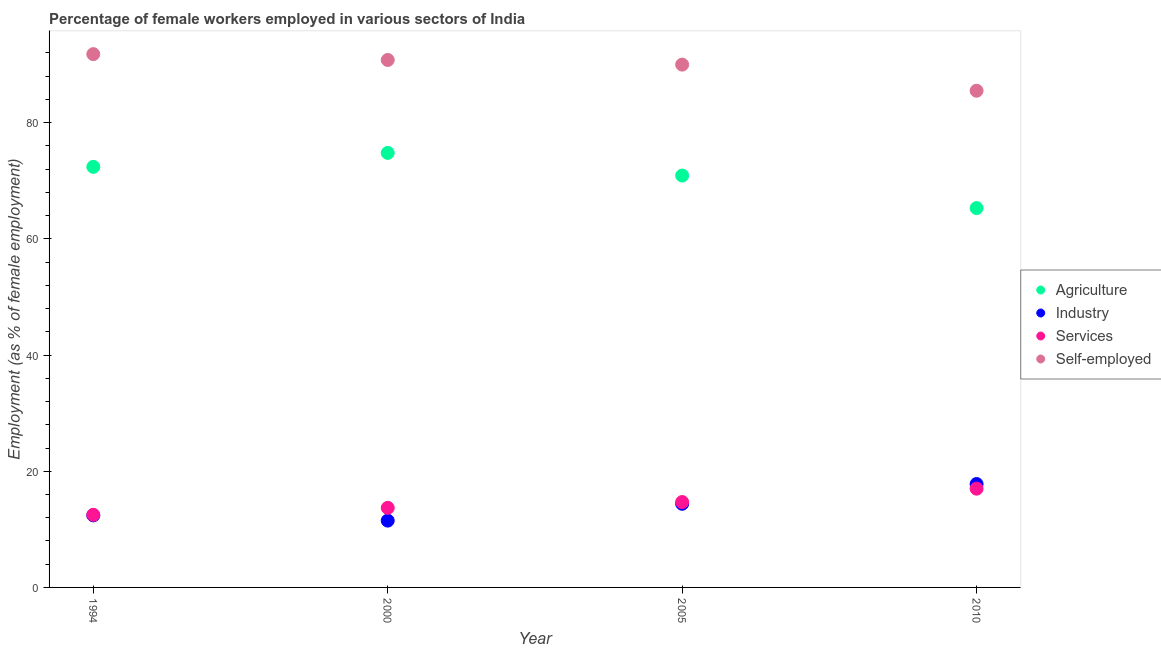How many different coloured dotlines are there?
Make the answer very short. 4. Is the number of dotlines equal to the number of legend labels?
Your answer should be compact. Yes. What is the percentage of female workers in industry in 1994?
Your answer should be compact. 12.4. Across all years, what is the maximum percentage of self employed female workers?
Your response must be concise. 91.8. In which year was the percentage of female workers in agriculture maximum?
Keep it short and to the point. 2000. In which year was the percentage of female workers in agriculture minimum?
Make the answer very short. 2010. What is the total percentage of female workers in industry in the graph?
Your answer should be very brief. 56.1. What is the difference between the percentage of self employed female workers in 2000 and that in 2005?
Keep it short and to the point. 0.8. What is the difference between the percentage of female workers in agriculture in 2000 and the percentage of self employed female workers in 2005?
Give a very brief answer. -15.2. What is the average percentage of self employed female workers per year?
Your answer should be compact. 89.53. In the year 1994, what is the difference between the percentage of female workers in agriculture and percentage of female workers in services?
Offer a terse response. 59.9. In how many years, is the percentage of female workers in services greater than 80 %?
Provide a succinct answer. 0. What is the ratio of the percentage of female workers in industry in 1994 to that in 2010?
Your response must be concise. 0.7. Is the percentage of self employed female workers in 2005 less than that in 2010?
Give a very brief answer. No. Is the difference between the percentage of female workers in agriculture in 1994 and 2005 greater than the difference between the percentage of self employed female workers in 1994 and 2005?
Your answer should be very brief. No. What is the difference between the highest and the second highest percentage of self employed female workers?
Provide a short and direct response. 1. What is the difference between the highest and the lowest percentage of female workers in industry?
Your response must be concise. 6.3. In how many years, is the percentage of self employed female workers greater than the average percentage of self employed female workers taken over all years?
Provide a succinct answer. 3. Is the sum of the percentage of female workers in agriculture in 1994 and 2000 greater than the maximum percentage of female workers in services across all years?
Make the answer very short. Yes. Is it the case that in every year, the sum of the percentage of female workers in agriculture and percentage of female workers in industry is greater than the percentage of female workers in services?
Offer a very short reply. Yes. Does the percentage of self employed female workers monotonically increase over the years?
Give a very brief answer. No. Is the percentage of self employed female workers strictly greater than the percentage of female workers in industry over the years?
Offer a very short reply. Yes. Does the graph contain any zero values?
Give a very brief answer. No. Does the graph contain grids?
Offer a terse response. No. Where does the legend appear in the graph?
Ensure brevity in your answer.  Center right. How many legend labels are there?
Your response must be concise. 4. How are the legend labels stacked?
Provide a succinct answer. Vertical. What is the title of the graph?
Make the answer very short. Percentage of female workers employed in various sectors of India. Does "WFP" appear as one of the legend labels in the graph?
Offer a terse response. No. What is the label or title of the X-axis?
Keep it short and to the point. Year. What is the label or title of the Y-axis?
Ensure brevity in your answer.  Employment (as % of female employment). What is the Employment (as % of female employment) of Agriculture in 1994?
Ensure brevity in your answer.  72.4. What is the Employment (as % of female employment) of Industry in 1994?
Give a very brief answer. 12.4. What is the Employment (as % of female employment) of Self-employed in 1994?
Offer a very short reply. 91.8. What is the Employment (as % of female employment) of Agriculture in 2000?
Offer a terse response. 74.8. What is the Employment (as % of female employment) of Services in 2000?
Provide a short and direct response. 13.7. What is the Employment (as % of female employment) of Self-employed in 2000?
Your response must be concise. 90.8. What is the Employment (as % of female employment) of Agriculture in 2005?
Make the answer very short. 70.9. What is the Employment (as % of female employment) in Industry in 2005?
Provide a succinct answer. 14.4. What is the Employment (as % of female employment) in Services in 2005?
Provide a short and direct response. 14.7. What is the Employment (as % of female employment) in Agriculture in 2010?
Offer a terse response. 65.3. What is the Employment (as % of female employment) in Industry in 2010?
Make the answer very short. 17.8. What is the Employment (as % of female employment) in Self-employed in 2010?
Your response must be concise. 85.5. Across all years, what is the maximum Employment (as % of female employment) of Agriculture?
Keep it short and to the point. 74.8. Across all years, what is the maximum Employment (as % of female employment) of Industry?
Offer a very short reply. 17.8. Across all years, what is the maximum Employment (as % of female employment) in Self-employed?
Provide a short and direct response. 91.8. Across all years, what is the minimum Employment (as % of female employment) in Agriculture?
Provide a short and direct response. 65.3. Across all years, what is the minimum Employment (as % of female employment) of Industry?
Your response must be concise. 11.5. Across all years, what is the minimum Employment (as % of female employment) of Services?
Offer a terse response. 12.5. Across all years, what is the minimum Employment (as % of female employment) in Self-employed?
Your answer should be very brief. 85.5. What is the total Employment (as % of female employment) of Agriculture in the graph?
Ensure brevity in your answer.  283.4. What is the total Employment (as % of female employment) in Industry in the graph?
Offer a very short reply. 56.1. What is the total Employment (as % of female employment) of Services in the graph?
Offer a very short reply. 57.9. What is the total Employment (as % of female employment) of Self-employed in the graph?
Offer a very short reply. 358.1. What is the difference between the Employment (as % of female employment) in Agriculture in 1994 and that in 2000?
Give a very brief answer. -2.4. What is the difference between the Employment (as % of female employment) in Industry in 1994 and that in 2000?
Make the answer very short. 0.9. What is the difference between the Employment (as % of female employment) in Self-employed in 1994 and that in 2000?
Provide a short and direct response. 1. What is the difference between the Employment (as % of female employment) in Agriculture in 1994 and that in 2005?
Offer a terse response. 1.5. What is the difference between the Employment (as % of female employment) of Industry in 1994 and that in 2005?
Your response must be concise. -2. What is the difference between the Employment (as % of female employment) of Services in 1994 and that in 2005?
Make the answer very short. -2.2. What is the difference between the Employment (as % of female employment) in Self-employed in 1994 and that in 2005?
Your answer should be compact. 1.8. What is the difference between the Employment (as % of female employment) of Industry in 2000 and that in 2010?
Your response must be concise. -6.3. What is the difference between the Employment (as % of female employment) of Industry in 2005 and that in 2010?
Offer a very short reply. -3.4. What is the difference between the Employment (as % of female employment) of Agriculture in 1994 and the Employment (as % of female employment) of Industry in 2000?
Keep it short and to the point. 60.9. What is the difference between the Employment (as % of female employment) of Agriculture in 1994 and the Employment (as % of female employment) of Services in 2000?
Your response must be concise. 58.7. What is the difference between the Employment (as % of female employment) of Agriculture in 1994 and the Employment (as % of female employment) of Self-employed in 2000?
Your response must be concise. -18.4. What is the difference between the Employment (as % of female employment) of Industry in 1994 and the Employment (as % of female employment) of Services in 2000?
Offer a terse response. -1.3. What is the difference between the Employment (as % of female employment) in Industry in 1994 and the Employment (as % of female employment) in Self-employed in 2000?
Your response must be concise. -78.4. What is the difference between the Employment (as % of female employment) in Services in 1994 and the Employment (as % of female employment) in Self-employed in 2000?
Your answer should be very brief. -78.3. What is the difference between the Employment (as % of female employment) of Agriculture in 1994 and the Employment (as % of female employment) of Services in 2005?
Ensure brevity in your answer.  57.7. What is the difference between the Employment (as % of female employment) of Agriculture in 1994 and the Employment (as % of female employment) of Self-employed in 2005?
Your answer should be very brief. -17.6. What is the difference between the Employment (as % of female employment) in Industry in 1994 and the Employment (as % of female employment) in Services in 2005?
Your answer should be compact. -2.3. What is the difference between the Employment (as % of female employment) in Industry in 1994 and the Employment (as % of female employment) in Self-employed in 2005?
Provide a short and direct response. -77.6. What is the difference between the Employment (as % of female employment) of Services in 1994 and the Employment (as % of female employment) of Self-employed in 2005?
Keep it short and to the point. -77.5. What is the difference between the Employment (as % of female employment) of Agriculture in 1994 and the Employment (as % of female employment) of Industry in 2010?
Provide a succinct answer. 54.6. What is the difference between the Employment (as % of female employment) in Agriculture in 1994 and the Employment (as % of female employment) in Services in 2010?
Make the answer very short. 55.4. What is the difference between the Employment (as % of female employment) of Industry in 1994 and the Employment (as % of female employment) of Self-employed in 2010?
Provide a short and direct response. -73.1. What is the difference between the Employment (as % of female employment) of Services in 1994 and the Employment (as % of female employment) of Self-employed in 2010?
Provide a succinct answer. -73. What is the difference between the Employment (as % of female employment) in Agriculture in 2000 and the Employment (as % of female employment) in Industry in 2005?
Offer a terse response. 60.4. What is the difference between the Employment (as % of female employment) of Agriculture in 2000 and the Employment (as % of female employment) of Services in 2005?
Keep it short and to the point. 60.1. What is the difference between the Employment (as % of female employment) of Agriculture in 2000 and the Employment (as % of female employment) of Self-employed in 2005?
Your answer should be very brief. -15.2. What is the difference between the Employment (as % of female employment) of Industry in 2000 and the Employment (as % of female employment) of Services in 2005?
Your answer should be compact. -3.2. What is the difference between the Employment (as % of female employment) of Industry in 2000 and the Employment (as % of female employment) of Self-employed in 2005?
Your answer should be compact. -78.5. What is the difference between the Employment (as % of female employment) of Services in 2000 and the Employment (as % of female employment) of Self-employed in 2005?
Give a very brief answer. -76.3. What is the difference between the Employment (as % of female employment) of Agriculture in 2000 and the Employment (as % of female employment) of Industry in 2010?
Give a very brief answer. 57. What is the difference between the Employment (as % of female employment) of Agriculture in 2000 and the Employment (as % of female employment) of Services in 2010?
Keep it short and to the point. 57.8. What is the difference between the Employment (as % of female employment) in Industry in 2000 and the Employment (as % of female employment) in Services in 2010?
Your response must be concise. -5.5. What is the difference between the Employment (as % of female employment) in Industry in 2000 and the Employment (as % of female employment) in Self-employed in 2010?
Make the answer very short. -74. What is the difference between the Employment (as % of female employment) in Services in 2000 and the Employment (as % of female employment) in Self-employed in 2010?
Keep it short and to the point. -71.8. What is the difference between the Employment (as % of female employment) in Agriculture in 2005 and the Employment (as % of female employment) in Industry in 2010?
Your answer should be compact. 53.1. What is the difference between the Employment (as % of female employment) in Agriculture in 2005 and the Employment (as % of female employment) in Services in 2010?
Keep it short and to the point. 53.9. What is the difference between the Employment (as % of female employment) in Agriculture in 2005 and the Employment (as % of female employment) in Self-employed in 2010?
Your answer should be very brief. -14.6. What is the difference between the Employment (as % of female employment) of Industry in 2005 and the Employment (as % of female employment) of Services in 2010?
Your answer should be compact. -2.6. What is the difference between the Employment (as % of female employment) in Industry in 2005 and the Employment (as % of female employment) in Self-employed in 2010?
Provide a succinct answer. -71.1. What is the difference between the Employment (as % of female employment) of Services in 2005 and the Employment (as % of female employment) of Self-employed in 2010?
Make the answer very short. -70.8. What is the average Employment (as % of female employment) of Agriculture per year?
Offer a very short reply. 70.85. What is the average Employment (as % of female employment) of Industry per year?
Make the answer very short. 14.03. What is the average Employment (as % of female employment) in Services per year?
Your response must be concise. 14.47. What is the average Employment (as % of female employment) of Self-employed per year?
Provide a succinct answer. 89.53. In the year 1994, what is the difference between the Employment (as % of female employment) in Agriculture and Employment (as % of female employment) in Industry?
Offer a terse response. 60. In the year 1994, what is the difference between the Employment (as % of female employment) of Agriculture and Employment (as % of female employment) of Services?
Keep it short and to the point. 59.9. In the year 1994, what is the difference between the Employment (as % of female employment) of Agriculture and Employment (as % of female employment) of Self-employed?
Provide a short and direct response. -19.4. In the year 1994, what is the difference between the Employment (as % of female employment) in Industry and Employment (as % of female employment) in Self-employed?
Provide a short and direct response. -79.4. In the year 1994, what is the difference between the Employment (as % of female employment) of Services and Employment (as % of female employment) of Self-employed?
Offer a very short reply. -79.3. In the year 2000, what is the difference between the Employment (as % of female employment) of Agriculture and Employment (as % of female employment) of Industry?
Keep it short and to the point. 63.3. In the year 2000, what is the difference between the Employment (as % of female employment) of Agriculture and Employment (as % of female employment) of Services?
Keep it short and to the point. 61.1. In the year 2000, what is the difference between the Employment (as % of female employment) of Industry and Employment (as % of female employment) of Services?
Provide a short and direct response. -2.2. In the year 2000, what is the difference between the Employment (as % of female employment) in Industry and Employment (as % of female employment) in Self-employed?
Give a very brief answer. -79.3. In the year 2000, what is the difference between the Employment (as % of female employment) in Services and Employment (as % of female employment) in Self-employed?
Make the answer very short. -77.1. In the year 2005, what is the difference between the Employment (as % of female employment) of Agriculture and Employment (as % of female employment) of Industry?
Provide a succinct answer. 56.5. In the year 2005, what is the difference between the Employment (as % of female employment) in Agriculture and Employment (as % of female employment) in Services?
Your answer should be very brief. 56.2. In the year 2005, what is the difference between the Employment (as % of female employment) in Agriculture and Employment (as % of female employment) in Self-employed?
Give a very brief answer. -19.1. In the year 2005, what is the difference between the Employment (as % of female employment) of Industry and Employment (as % of female employment) of Services?
Your answer should be very brief. -0.3. In the year 2005, what is the difference between the Employment (as % of female employment) in Industry and Employment (as % of female employment) in Self-employed?
Keep it short and to the point. -75.6. In the year 2005, what is the difference between the Employment (as % of female employment) in Services and Employment (as % of female employment) in Self-employed?
Offer a terse response. -75.3. In the year 2010, what is the difference between the Employment (as % of female employment) in Agriculture and Employment (as % of female employment) in Industry?
Provide a succinct answer. 47.5. In the year 2010, what is the difference between the Employment (as % of female employment) of Agriculture and Employment (as % of female employment) of Services?
Provide a succinct answer. 48.3. In the year 2010, what is the difference between the Employment (as % of female employment) in Agriculture and Employment (as % of female employment) in Self-employed?
Provide a succinct answer. -20.2. In the year 2010, what is the difference between the Employment (as % of female employment) in Industry and Employment (as % of female employment) in Self-employed?
Offer a terse response. -67.7. In the year 2010, what is the difference between the Employment (as % of female employment) of Services and Employment (as % of female employment) of Self-employed?
Make the answer very short. -68.5. What is the ratio of the Employment (as % of female employment) of Agriculture in 1994 to that in 2000?
Offer a very short reply. 0.97. What is the ratio of the Employment (as % of female employment) of Industry in 1994 to that in 2000?
Make the answer very short. 1.08. What is the ratio of the Employment (as % of female employment) of Services in 1994 to that in 2000?
Your answer should be very brief. 0.91. What is the ratio of the Employment (as % of female employment) in Agriculture in 1994 to that in 2005?
Your answer should be very brief. 1.02. What is the ratio of the Employment (as % of female employment) of Industry in 1994 to that in 2005?
Keep it short and to the point. 0.86. What is the ratio of the Employment (as % of female employment) of Services in 1994 to that in 2005?
Your answer should be very brief. 0.85. What is the ratio of the Employment (as % of female employment) of Self-employed in 1994 to that in 2005?
Provide a succinct answer. 1.02. What is the ratio of the Employment (as % of female employment) of Agriculture in 1994 to that in 2010?
Your answer should be very brief. 1.11. What is the ratio of the Employment (as % of female employment) in Industry in 1994 to that in 2010?
Offer a very short reply. 0.7. What is the ratio of the Employment (as % of female employment) in Services in 1994 to that in 2010?
Your answer should be very brief. 0.74. What is the ratio of the Employment (as % of female employment) in Self-employed in 1994 to that in 2010?
Provide a short and direct response. 1.07. What is the ratio of the Employment (as % of female employment) in Agriculture in 2000 to that in 2005?
Your answer should be very brief. 1.05. What is the ratio of the Employment (as % of female employment) of Industry in 2000 to that in 2005?
Give a very brief answer. 0.8. What is the ratio of the Employment (as % of female employment) of Services in 2000 to that in 2005?
Your response must be concise. 0.93. What is the ratio of the Employment (as % of female employment) in Self-employed in 2000 to that in 2005?
Your response must be concise. 1.01. What is the ratio of the Employment (as % of female employment) in Agriculture in 2000 to that in 2010?
Offer a very short reply. 1.15. What is the ratio of the Employment (as % of female employment) of Industry in 2000 to that in 2010?
Offer a very short reply. 0.65. What is the ratio of the Employment (as % of female employment) of Services in 2000 to that in 2010?
Offer a very short reply. 0.81. What is the ratio of the Employment (as % of female employment) of Self-employed in 2000 to that in 2010?
Make the answer very short. 1.06. What is the ratio of the Employment (as % of female employment) of Agriculture in 2005 to that in 2010?
Your answer should be very brief. 1.09. What is the ratio of the Employment (as % of female employment) of Industry in 2005 to that in 2010?
Keep it short and to the point. 0.81. What is the ratio of the Employment (as % of female employment) of Services in 2005 to that in 2010?
Make the answer very short. 0.86. What is the ratio of the Employment (as % of female employment) in Self-employed in 2005 to that in 2010?
Provide a succinct answer. 1.05. What is the difference between the highest and the lowest Employment (as % of female employment) in Agriculture?
Your answer should be very brief. 9.5. What is the difference between the highest and the lowest Employment (as % of female employment) in Services?
Give a very brief answer. 4.5. What is the difference between the highest and the lowest Employment (as % of female employment) in Self-employed?
Your response must be concise. 6.3. 